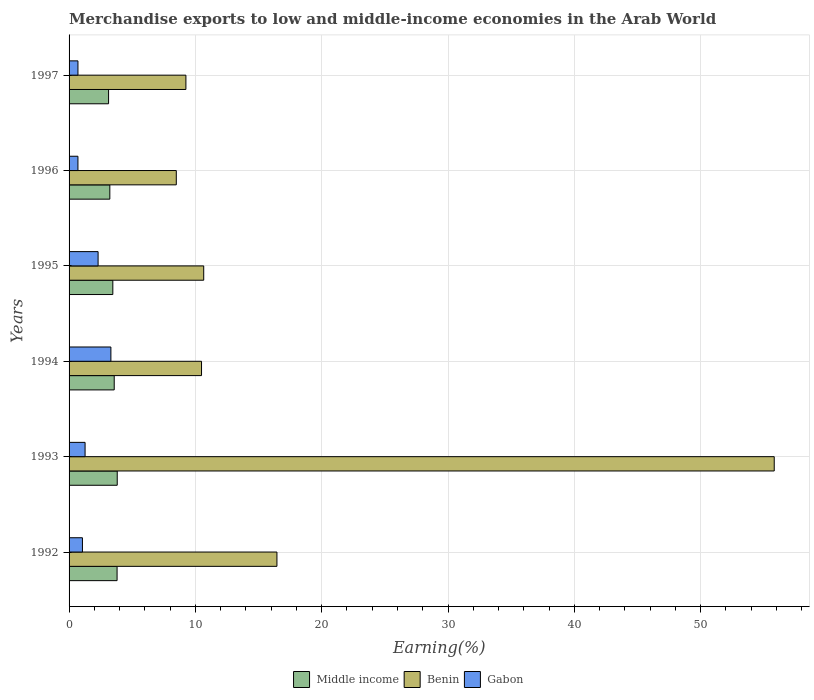How many groups of bars are there?
Ensure brevity in your answer.  6. Are the number of bars per tick equal to the number of legend labels?
Your answer should be very brief. Yes. Are the number of bars on each tick of the Y-axis equal?
Ensure brevity in your answer.  Yes. How many bars are there on the 6th tick from the bottom?
Offer a terse response. 3. In how many cases, is the number of bars for a given year not equal to the number of legend labels?
Provide a succinct answer. 0. What is the percentage of amount earned from merchandise exports in Gabon in 1992?
Give a very brief answer. 1.06. Across all years, what is the maximum percentage of amount earned from merchandise exports in Middle income?
Your answer should be very brief. 3.81. Across all years, what is the minimum percentage of amount earned from merchandise exports in Gabon?
Provide a succinct answer. 0.7. In which year was the percentage of amount earned from merchandise exports in Gabon minimum?
Provide a short and direct response. 1996. What is the total percentage of amount earned from merchandise exports in Benin in the graph?
Your answer should be compact. 111.17. What is the difference between the percentage of amount earned from merchandise exports in Gabon in 1993 and that in 1996?
Offer a terse response. 0.57. What is the difference between the percentage of amount earned from merchandise exports in Gabon in 1992 and the percentage of amount earned from merchandise exports in Benin in 1997?
Provide a succinct answer. -8.19. What is the average percentage of amount earned from merchandise exports in Middle income per year?
Your answer should be very brief. 3.5. In the year 1997, what is the difference between the percentage of amount earned from merchandise exports in Benin and percentage of amount earned from merchandise exports in Gabon?
Ensure brevity in your answer.  8.55. What is the ratio of the percentage of amount earned from merchandise exports in Benin in 1992 to that in 1993?
Offer a terse response. 0.29. Is the percentage of amount earned from merchandise exports in Benin in 1992 less than that in 1995?
Keep it short and to the point. No. Is the difference between the percentage of amount earned from merchandise exports in Benin in 1993 and 1997 greater than the difference between the percentage of amount earned from merchandise exports in Gabon in 1993 and 1997?
Offer a very short reply. Yes. What is the difference between the highest and the second highest percentage of amount earned from merchandise exports in Gabon?
Ensure brevity in your answer.  1.01. What is the difference between the highest and the lowest percentage of amount earned from merchandise exports in Benin?
Give a very brief answer. 47.34. In how many years, is the percentage of amount earned from merchandise exports in Gabon greater than the average percentage of amount earned from merchandise exports in Gabon taken over all years?
Offer a terse response. 2. Is the sum of the percentage of amount earned from merchandise exports in Benin in 1994 and 1995 greater than the maximum percentage of amount earned from merchandise exports in Middle income across all years?
Make the answer very short. Yes. What does the 2nd bar from the bottom in 1995 represents?
Make the answer very short. Benin. How many bars are there?
Ensure brevity in your answer.  18. What is the difference between two consecutive major ticks on the X-axis?
Offer a very short reply. 10. Are the values on the major ticks of X-axis written in scientific E-notation?
Your answer should be compact. No. Does the graph contain grids?
Give a very brief answer. Yes. How are the legend labels stacked?
Make the answer very short. Horizontal. What is the title of the graph?
Your answer should be very brief. Merchandise exports to low and middle-income economies in the Arab World. Does "OECD members" appear as one of the legend labels in the graph?
Keep it short and to the point. No. What is the label or title of the X-axis?
Keep it short and to the point. Earning(%). What is the label or title of the Y-axis?
Offer a terse response. Years. What is the Earning(%) in Middle income in 1992?
Give a very brief answer. 3.8. What is the Earning(%) of Benin in 1992?
Your response must be concise. 16.46. What is the Earning(%) of Gabon in 1992?
Give a very brief answer. 1.06. What is the Earning(%) in Middle income in 1993?
Keep it short and to the point. 3.81. What is the Earning(%) of Benin in 1993?
Offer a terse response. 55.83. What is the Earning(%) in Gabon in 1993?
Provide a short and direct response. 1.27. What is the Earning(%) in Middle income in 1994?
Make the answer very short. 3.57. What is the Earning(%) of Benin in 1994?
Offer a very short reply. 10.49. What is the Earning(%) of Gabon in 1994?
Your answer should be compact. 3.31. What is the Earning(%) in Middle income in 1995?
Ensure brevity in your answer.  3.46. What is the Earning(%) of Benin in 1995?
Make the answer very short. 10.66. What is the Earning(%) of Gabon in 1995?
Offer a terse response. 2.3. What is the Earning(%) in Middle income in 1996?
Your answer should be very brief. 3.23. What is the Earning(%) in Benin in 1996?
Ensure brevity in your answer.  8.49. What is the Earning(%) of Gabon in 1996?
Make the answer very short. 0.7. What is the Earning(%) in Middle income in 1997?
Offer a terse response. 3.13. What is the Earning(%) in Benin in 1997?
Keep it short and to the point. 9.25. What is the Earning(%) in Gabon in 1997?
Your answer should be compact. 0.7. Across all years, what is the maximum Earning(%) of Middle income?
Provide a succinct answer. 3.81. Across all years, what is the maximum Earning(%) of Benin?
Offer a terse response. 55.83. Across all years, what is the maximum Earning(%) in Gabon?
Provide a short and direct response. 3.31. Across all years, what is the minimum Earning(%) in Middle income?
Your response must be concise. 3.13. Across all years, what is the minimum Earning(%) in Benin?
Ensure brevity in your answer.  8.49. Across all years, what is the minimum Earning(%) in Gabon?
Ensure brevity in your answer.  0.7. What is the total Earning(%) of Middle income in the graph?
Your answer should be compact. 21.01. What is the total Earning(%) of Benin in the graph?
Provide a short and direct response. 111.17. What is the total Earning(%) in Gabon in the graph?
Provide a short and direct response. 9.34. What is the difference between the Earning(%) in Middle income in 1992 and that in 1993?
Provide a short and direct response. -0.01. What is the difference between the Earning(%) in Benin in 1992 and that in 1993?
Provide a succinct answer. -39.37. What is the difference between the Earning(%) of Gabon in 1992 and that in 1993?
Provide a short and direct response. -0.21. What is the difference between the Earning(%) in Middle income in 1992 and that in 1994?
Make the answer very short. 0.23. What is the difference between the Earning(%) in Benin in 1992 and that in 1994?
Ensure brevity in your answer.  5.97. What is the difference between the Earning(%) of Gabon in 1992 and that in 1994?
Offer a very short reply. -2.25. What is the difference between the Earning(%) in Middle income in 1992 and that in 1995?
Give a very brief answer. 0.34. What is the difference between the Earning(%) in Benin in 1992 and that in 1995?
Your answer should be compact. 5.8. What is the difference between the Earning(%) in Gabon in 1992 and that in 1995?
Your answer should be very brief. -1.24. What is the difference between the Earning(%) in Middle income in 1992 and that in 1996?
Provide a short and direct response. 0.57. What is the difference between the Earning(%) of Benin in 1992 and that in 1996?
Your answer should be compact. 7.97. What is the difference between the Earning(%) of Gabon in 1992 and that in 1996?
Offer a terse response. 0.36. What is the difference between the Earning(%) of Middle income in 1992 and that in 1997?
Your answer should be compact. 0.67. What is the difference between the Earning(%) in Benin in 1992 and that in 1997?
Provide a succinct answer. 7.21. What is the difference between the Earning(%) in Gabon in 1992 and that in 1997?
Ensure brevity in your answer.  0.35. What is the difference between the Earning(%) of Middle income in 1993 and that in 1994?
Ensure brevity in your answer.  0.24. What is the difference between the Earning(%) of Benin in 1993 and that in 1994?
Offer a very short reply. 45.34. What is the difference between the Earning(%) in Gabon in 1993 and that in 1994?
Provide a short and direct response. -2.04. What is the difference between the Earning(%) in Middle income in 1993 and that in 1995?
Offer a very short reply. 0.35. What is the difference between the Earning(%) in Benin in 1993 and that in 1995?
Offer a very short reply. 45.17. What is the difference between the Earning(%) in Gabon in 1993 and that in 1995?
Provide a short and direct response. -1.03. What is the difference between the Earning(%) of Middle income in 1993 and that in 1996?
Offer a very short reply. 0.59. What is the difference between the Earning(%) of Benin in 1993 and that in 1996?
Offer a very short reply. 47.34. What is the difference between the Earning(%) of Gabon in 1993 and that in 1996?
Your response must be concise. 0.57. What is the difference between the Earning(%) of Middle income in 1993 and that in 1997?
Give a very brief answer. 0.69. What is the difference between the Earning(%) of Benin in 1993 and that in 1997?
Offer a terse response. 46.58. What is the difference between the Earning(%) of Gabon in 1993 and that in 1997?
Your response must be concise. 0.56. What is the difference between the Earning(%) in Middle income in 1994 and that in 1995?
Ensure brevity in your answer.  0.11. What is the difference between the Earning(%) of Benin in 1994 and that in 1995?
Ensure brevity in your answer.  -0.17. What is the difference between the Earning(%) of Gabon in 1994 and that in 1995?
Make the answer very short. 1.01. What is the difference between the Earning(%) in Middle income in 1994 and that in 1996?
Ensure brevity in your answer.  0.35. What is the difference between the Earning(%) in Benin in 1994 and that in 1996?
Ensure brevity in your answer.  2. What is the difference between the Earning(%) in Gabon in 1994 and that in 1996?
Offer a terse response. 2.61. What is the difference between the Earning(%) in Middle income in 1994 and that in 1997?
Your answer should be very brief. 0.45. What is the difference between the Earning(%) in Benin in 1994 and that in 1997?
Ensure brevity in your answer.  1.24. What is the difference between the Earning(%) in Gabon in 1994 and that in 1997?
Ensure brevity in your answer.  2.61. What is the difference between the Earning(%) of Middle income in 1995 and that in 1996?
Your answer should be compact. 0.24. What is the difference between the Earning(%) in Benin in 1995 and that in 1996?
Give a very brief answer. 2.17. What is the difference between the Earning(%) in Gabon in 1995 and that in 1996?
Ensure brevity in your answer.  1.6. What is the difference between the Earning(%) in Middle income in 1995 and that in 1997?
Your answer should be compact. 0.34. What is the difference between the Earning(%) of Benin in 1995 and that in 1997?
Offer a terse response. 1.41. What is the difference between the Earning(%) in Gabon in 1995 and that in 1997?
Ensure brevity in your answer.  1.59. What is the difference between the Earning(%) in Middle income in 1996 and that in 1997?
Keep it short and to the point. 0.1. What is the difference between the Earning(%) of Benin in 1996 and that in 1997?
Your answer should be compact. -0.76. What is the difference between the Earning(%) of Gabon in 1996 and that in 1997?
Make the answer very short. -0. What is the difference between the Earning(%) in Middle income in 1992 and the Earning(%) in Benin in 1993?
Give a very brief answer. -52.03. What is the difference between the Earning(%) of Middle income in 1992 and the Earning(%) of Gabon in 1993?
Your answer should be compact. 2.53. What is the difference between the Earning(%) of Benin in 1992 and the Earning(%) of Gabon in 1993?
Keep it short and to the point. 15.19. What is the difference between the Earning(%) in Middle income in 1992 and the Earning(%) in Benin in 1994?
Your response must be concise. -6.69. What is the difference between the Earning(%) in Middle income in 1992 and the Earning(%) in Gabon in 1994?
Ensure brevity in your answer.  0.49. What is the difference between the Earning(%) of Benin in 1992 and the Earning(%) of Gabon in 1994?
Provide a short and direct response. 13.15. What is the difference between the Earning(%) of Middle income in 1992 and the Earning(%) of Benin in 1995?
Give a very brief answer. -6.86. What is the difference between the Earning(%) of Middle income in 1992 and the Earning(%) of Gabon in 1995?
Make the answer very short. 1.5. What is the difference between the Earning(%) in Benin in 1992 and the Earning(%) in Gabon in 1995?
Provide a short and direct response. 14.16. What is the difference between the Earning(%) of Middle income in 1992 and the Earning(%) of Benin in 1996?
Make the answer very short. -4.69. What is the difference between the Earning(%) in Middle income in 1992 and the Earning(%) in Gabon in 1996?
Your response must be concise. 3.1. What is the difference between the Earning(%) in Benin in 1992 and the Earning(%) in Gabon in 1996?
Your answer should be very brief. 15.76. What is the difference between the Earning(%) in Middle income in 1992 and the Earning(%) in Benin in 1997?
Your response must be concise. -5.45. What is the difference between the Earning(%) in Middle income in 1992 and the Earning(%) in Gabon in 1997?
Give a very brief answer. 3.1. What is the difference between the Earning(%) of Benin in 1992 and the Earning(%) of Gabon in 1997?
Make the answer very short. 15.75. What is the difference between the Earning(%) of Middle income in 1993 and the Earning(%) of Benin in 1994?
Provide a short and direct response. -6.67. What is the difference between the Earning(%) of Middle income in 1993 and the Earning(%) of Gabon in 1994?
Keep it short and to the point. 0.5. What is the difference between the Earning(%) of Benin in 1993 and the Earning(%) of Gabon in 1994?
Ensure brevity in your answer.  52.52. What is the difference between the Earning(%) of Middle income in 1993 and the Earning(%) of Benin in 1995?
Your answer should be very brief. -6.85. What is the difference between the Earning(%) of Middle income in 1993 and the Earning(%) of Gabon in 1995?
Your response must be concise. 1.52. What is the difference between the Earning(%) of Benin in 1993 and the Earning(%) of Gabon in 1995?
Offer a terse response. 53.53. What is the difference between the Earning(%) of Middle income in 1993 and the Earning(%) of Benin in 1996?
Offer a very short reply. -4.68. What is the difference between the Earning(%) of Middle income in 1993 and the Earning(%) of Gabon in 1996?
Your answer should be very brief. 3.11. What is the difference between the Earning(%) in Benin in 1993 and the Earning(%) in Gabon in 1996?
Make the answer very short. 55.13. What is the difference between the Earning(%) in Middle income in 1993 and the Earning(%) in Benin in 1997?
Give a very brief answer. -5.44. What is the difference between the Earning(%) of Middle income in 1993 and the Earning(%) of Gabon in 1997?
Give a very brief answer. 3.11. What is the difference between the Earning(%) in Benin in 1993 and the Earning(%) in Gabon in 1997?
Your answer should be compact. 55.12. What is the difference between the Earning(%) in Middle income in 1994 and the Earning(%) in Benin in 1995?
Offer a terse response. -7.09. What is the difference between the Earning(%) in Middle income in 1994 and the Earning(%) in Gabon in 1995?
Provide a succinct answer. 1.28. What is the difference between the Earning(%) of Benin in 1994 and the Earning(%) of Gabon in 1995?
Your answer should be compact. 8.19. What is the difference between the Earning(%) in Middle income in 1994 and the Earning(%) in Benin in 1996?
Offer a terse response. -4.91. What is the difference between the Earning(%) of Middle income in 1994 and the Earning(%) of Gabon in 1996?
Make the answer very short. 2.87. What is the difference between the Earning(%) of Benin in 1994 and the Earning(%) of Gabon in 1996?
Ensure brevity in your answer.  9.79. What is the difference between the Earning(%) in Middle income in 1994 and the Earning(%) in Benin in 1997?
Your answer should be very brief. -5.68. What is the difference between the Earning(%) in Middle income in 1994 and the Earning(%) in Gabon in 1997?
Your answer should be compact. 2.87. What is the difference between the Earning(%) in Benin in 1994 and the Earning(%) in Gabon in 1997?
Provide a succinct answer. 9.78. What is the difference between the Earning(%) in Middle income in 1995 and the Earning(%) in Benin in 1996?
Make the answer very short. -5.03. What is the difference between the Earning(%) in Middle income in 1995 and the Earning(%) in Gabon in 1996?
Your answer should be very brief. 2.76. What is the difference between the Earning(%) in Benin in 1995 and the Earning(%) in Gabon in 1996?
Give a very brief answer. 9.96. What is the difference between the Earning(%) in Middle income in 1995 and the Earning(%) in Benin in 1997?
Make the answer very short. -5.79. What is the difference between the Earning(%) in Middle income in 1995 and the Earning(%) in Gabon in 1997?
Ensure brevity in your answer.  2.76. What is the difference between the Earning(%) in Benin in 1995 and the Earning(%) in Gabon in 1997?
Make the answer very short. 9.96. What is the difference between the Earning(%) in Middle income in 1996 and the Earning(%) in Benin in 1997?
Make the answer very short. -6.02. What is the difference between the Earning(%) in Middle income in 1996 and the Earning(%) in Gabon in 1997?
Offer a terse response. 2.52. What is the difference between the Earning(%) of Benin in 1996 and the Earning(%) of Gabon in 1997?
Your response must be concise. 7.79. What is the average Earning(%) of Middle income per year?
Your response must be concise. 3.5. What is the average Earning(%) in Benin per year?
Your answer should be compact. 18.53. What is the average Earning(%) in Gabon per year?
Provide a succinct answer. 1.56. In the year 1992, what is the difference between the Earning(%) in Middle income and Earning(%) in Benin?
Offer a very short reply. -12.66. In the year 1992, what is the difference between the Earning(%) of Middle income and Earning(%) of Gabon?
Your answer should be very brief. 2.74. In the year 1992, what is the difference between the Earning(%) in Benin and Earning(%) in Gabon?
Your answer should be very brief. 15.4. In the year 1993, what is the difference between the Earning(%) in Middle income and Earning(%) in Benin?
Your response must be concise. -52.01. In the year 1993, what is the difference between the Earning(%) in Middle income and Earning(%) in Gabon?
Ensure brevity in your answer.  2.55. In the year 1993, what is the difference between the Earning(%) in Benin and Earning(%) in Gabon?
Your answer should be very brief. 54.56. In the year 1994, what is the difference between the Earning(%) in Middle income and Earning(%) in Benin?
Give a very brief answer. -6.91. In the year 1994, what is the difference between the Earning(%) in Middle income and Earning(%) in Gabon?
Offer a very short reply. 0.26. In the year 1994, what is the difference between the Earning(%) in Benin and Earning(%) in Gabon?
Your answer should be very brief. 7.18. In the year 1995, what is the difference between the Earning(%) in Middle income and Earning(%) in Benin?
Your answer should be compact. -7.2. In the year 1995, what is the difference between the Earning(%) of Middle income and Earning(%) of Gabon?
Offer a very short reply. 1.17. In the year 1995, what is the difference between the Earning(%) of Benin and Earning(%) of Gabon?
Keep it short and to the point. 8.36. In the year 1996, what is the difference between the Earning(%) in Middle income and Earning(%) in Benin?
Your response must be concise. -5.26. In the year 1996, what is the difference between the Earning(%) of Middle income and Earning(%) of Gabon?
Provide a succinct answer. 2.53. In the year 1996, what is the difference between the Earning(%) of Benin and Earning(%) of Gabon?
Make the answer very short. 7.79. In the year 1997, what is the difference between the Earning(%) of Middle income and Earning(%) of Benin?
Your response must be concise. -6.12. In the year 1997, what is the difference between the Earning(%) of Middle income and Earning(%) of Gabon?
Ensure brevity in your answer.  2.42. In the year 1997, what is the difference between the Earning(%) of Benin and Earning(%) of Gabon?
Provide a short and direct response. 8.55. What is the ratio of the Earning(%) of Middle income in 1992 to that in 1993?
Provide a succinct answer. 1. What is the ratio of the Earning(%) of Benin in 1992 to that in 1993?
Offer a very short reply. 0.29. What is the ratio of the Earning(%) in Gabon in 1992 to that in 1993?
Your answer should be very brief. 0.83. What is the ratio of the Earning(%) of Middle income in 1992 to that in 1994?
Offer a very short reply. 1.06. What is the ratio of the Earning(%) in Benin in 1992 to that in 1994?
Make the answer very short. 1.57. What is the ratio of the Earning(%) in Gabon in 1992 to that in 1994?
Offer a terse response. 0.32. What is the ratio of the Earning(%) of Middle income in 1992 to that in 1995?
Offer a very short reply. 1.1. What is the ratio of the Earning(%) of Benin in 1992 to that in 1995?
Provide a short and direct response. 1.54. What is the ratio of the Earning(%) in Gabon in 1992 to that in 1995?
Provide a succinct answer. 0.46. What is the ratio of the Earning(%) in Middle income in 1992 to that in 1996?
Give a very brief answer. 1.18. What is the ratio of the Earning(%) in Benin in 1992 to that in 1996?
Ensure brevity in your answer.  1.94. What is the ratio of the Earning(%) of Gabon in 1992 to that in 1996?
Make the answer very short. 1.51. What is the ratio of the Earning(%) in Middle income in 1992 to that in 1997?
Give a very brief answer. 1.22. What is the ratio of the Earning(%) in Benin in 1992 to that in 1997?
Your response must be concise. 1.78. What is the ratio of the Earning(%) of Gabon in 1992 to that in 1997?
Your answer should be very brief. 1.5. What is the ratio of the Earning(%) of Middle income in 1993 to that in 1994?
Keep it short and to the point. 1.07. What is the ratio of the Earning(%) in Benin in 1993 to that in 1994?
Keep it short and to the point. 5.32. What is the ratio of the Earning(%) in Gabon in 1993 to that in 1994?
Ensure brevity in your answer.  0.38. What is the ratio of the Earning(%) in Middle income in 1993 to that in 1995?
Make the answer very short. 1.1. What is the ratio of the Earning(%) in Benin in 1993 to that in 1995?
Make the answer very short. 5.24. What is the ratio of the Earning(%) in Gabon in 1993 to that in 1995?
Your answer should be very brief. 0.55. What is the ratio of the Earning(%) in Middle income in 1993 to that in 1996?
Make the answer very short. 1.18. What is the ratio of the Earning(%) of Benin in 1993 to that in 1996?
Your answer should be very brief. 6.58. What is the ratio of the Earning(%) in Gabon in 1993 to that in 1996?
Your answer should be compact. 1.81. What is the ratio of the Earning(%) in Middle income in 1993 to that in 1997?
Offer a very short reply. 1.22. What is the ratio of the Earning(%) of Benin in 1993 to that in 1997?
Ensure brevity in your answer.  6.04. What is the ratio of the Earning(%) of Gabon in 1993 to that in 1997?
Offer a terse response. 1.8. What is the ratio of the Earning(%) of Middle income in 1994 to that in 1995?
Keep it short and to the point. 1.03. What is the ratio of the Earning(%) of Benin in 1994 to that in 1995?
Give a very brief answer. 0.98. What is the ratio of the Earning(%) of Gabon in 1994 to that in 1995?
Provide a succinct answer. 1.44. What is the ratio of the Earning(%) in Middle income in 1994 to that in 1996?
Offer a very short reply. 1.11. What is the ratio of the Earning(%) in Benin in 1994 to that in 1996?
Your answer should be compact. 1.24. What is the ratio of the Earning(%) in Gabon in 1994 to that in 1996?
Offer a very short reply. 4.72. What is the ratio of the Earning(%) in Middle income in 1994 to that in 1997?
Provide a succinct answer. 1.14. What is the ratio of the Earning(%) in Benin in 1994 to that in 1997?
Offer a very short reply. 1.13. What is the ratio of the Earning(%) in Gabon in 1994 to that in 1997?
Ensure brevity in your answer.  4.71. What is the ratio of the Earning(%) in Middle income in 1995 to that in 1996?
Ensure brevity in your answer.  1.07. What is the ratio of the Earning(%) in Benin in 1995 to that in 1996?
Provide a short and direct response. 1.26. What is the ratio of the Earning(%) in Gabon in 1995 to that in 1996?
Your response must be concise. 3.28. What is the ratio of the Earning(%) in Middle income in 1995 to that in 1997?
Your answer should be very brief. 1.11. What is the ratio of the Earning(%) in Benin in 1995 to that in 1997?
Provide a succinct answer. 1.15. What is the ratio of the Earning(%) of Gabon in 1995 to that in 1997?
Keep it short and to the point. 3.27. What is the ratio of the Earning(%) in Middle income in 1996 to that in 1997?
Ensure brevity in your answer.  1.03. What is the ratio of the Earning(%) in Benin in 1996 to that in 1997?
Your response must be concise. 0.92. What is the difference between the highest and the second highest Earning(%) in Middle income?
Your response must be concise. 0.01. What is the difference between the highest and the second highest Earning(%) of Benin?
Offer a terse response. 39.37. What is the difference between the highest and the second highest Earning(%) of Gabon?
Your answer should be compact. 1.01. What is the difference between the highest and the lowest Earning(%) of Middle income?
Ensure brevity in your answer.  0.69. What is the difference between the highest and the lowest Earning(%) of Benin?
Your answer should be compact. 47.34. What is the difference between the highest and the lowest Earning(%) of Gabon?
Keep it short and to the point. 2.61. 